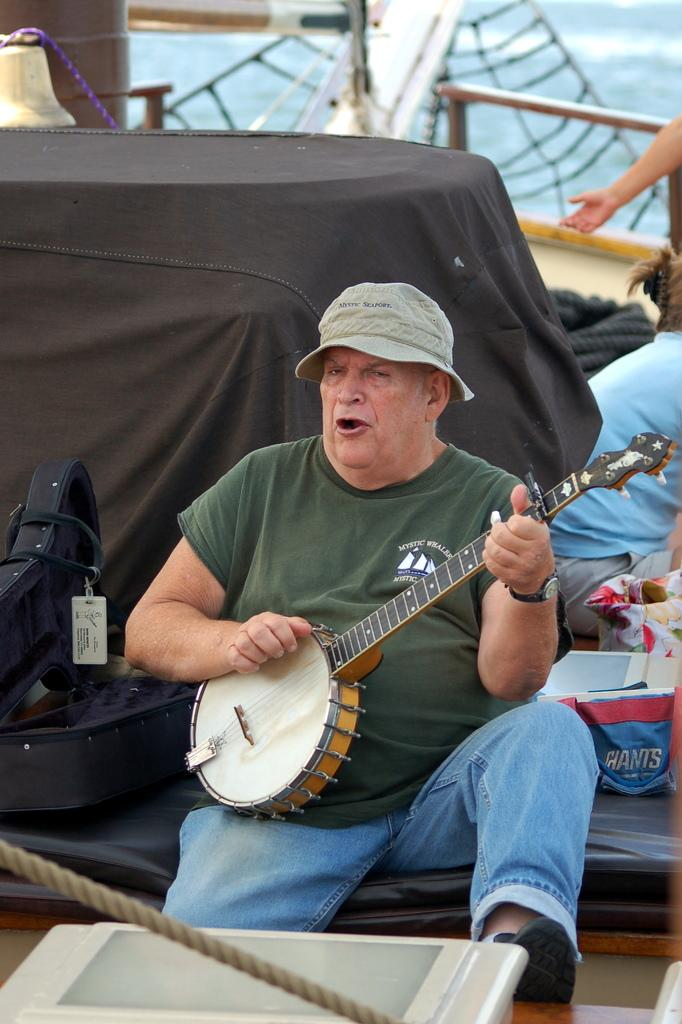What is the main subject of the image? There is a person in the image. What is the person wearing on their upper body? The person is wearing a green T-shirt. What type of headwear is the person wearing? The person is wearing a hat. What activity is the person engaged in? The person is playing a musical instrument. What color is the sheet in the background of the image? There is a black color sheet in the background of the image. Can you tell me how many swings are visible in the image? There are no swings present in the image; it features a person playing a musical instrument. What color are the person's eyes in the image? The color of the person's eyes cannot be determined from the image, as it only shows the person from the neck up. 